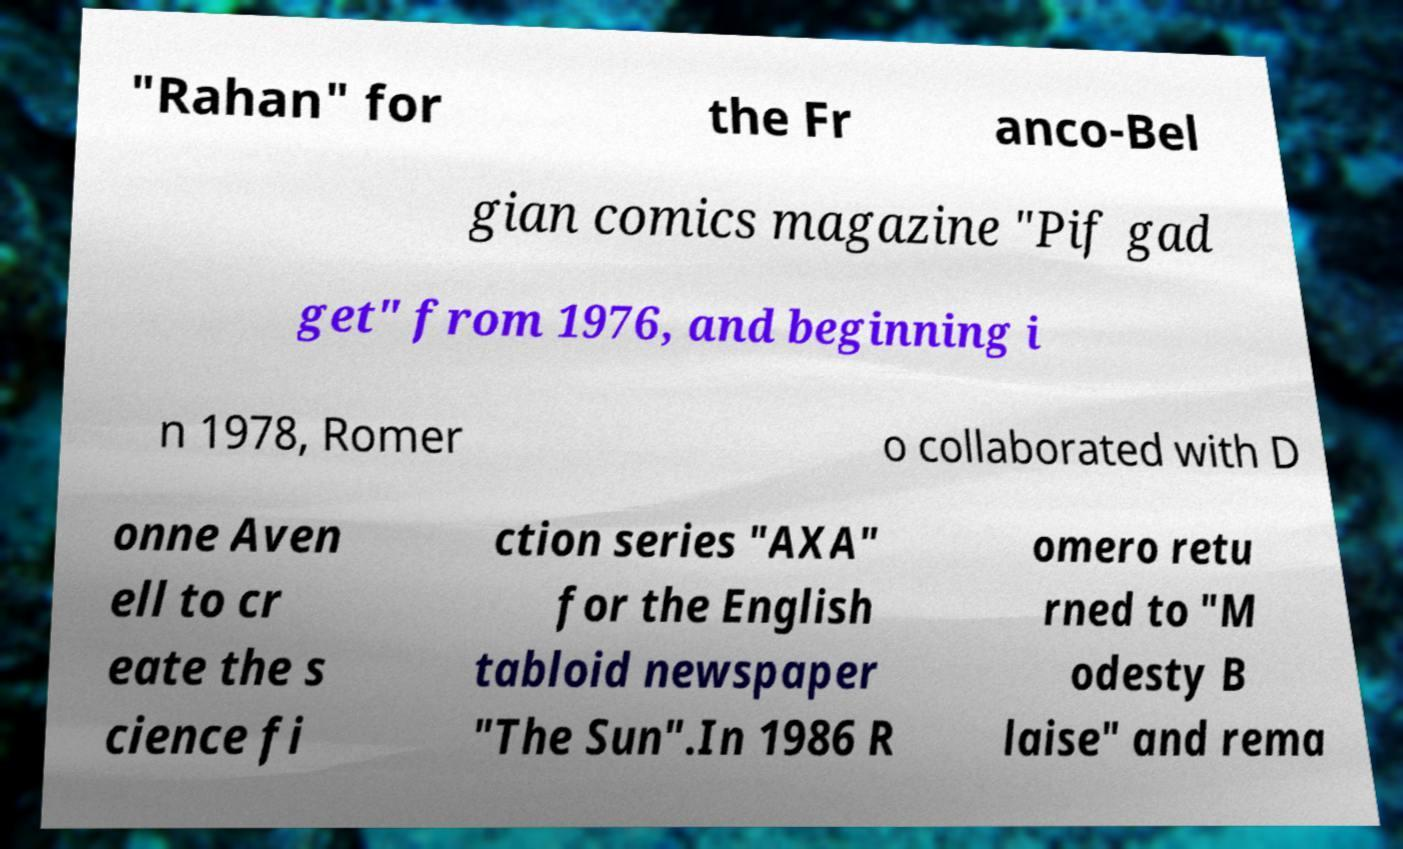Please read and relay the text visible in this image. What does it say? "Rahan" for the Fr anco-Bel gian comics magazine "Pif gad get" from 1976, and beginning i n 1978, Romer o collaborated with D onne Aven ell to cr eate the s cience fi ction series "AXA" for the English tabloid newspaper "The Sun".In 1986 R omero retu rned to "M odesty B laise" and rema 